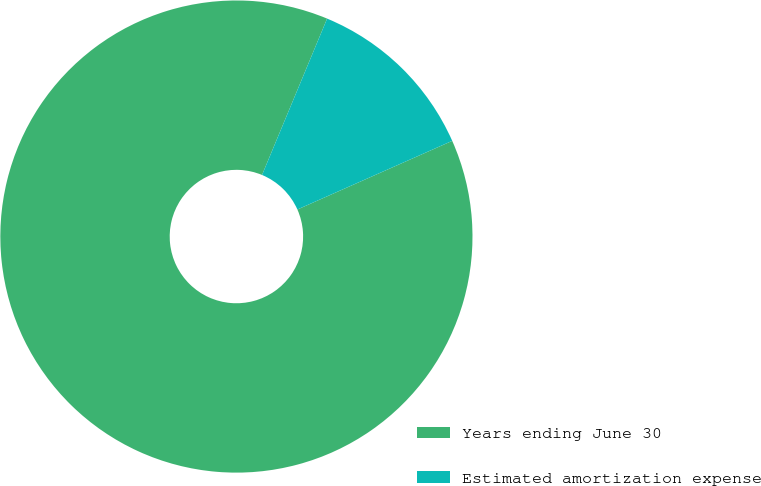<chart> <loc_0><loc_0><loc_500><loc_500><pie_chart><fcel>Years ending June 30<fcel>Estimated amortization expense<nl><fcel>87.92%<fcel>12.08%<nl></chart> 